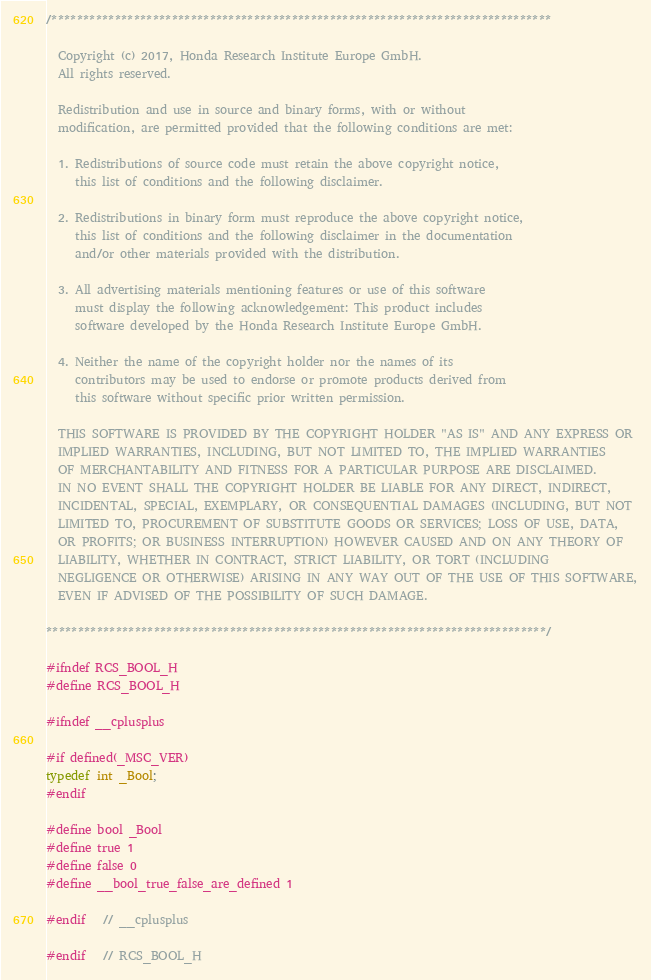<code> <loc_0><loc_0><loc_500><loc_500><_C_>/*******************************************************************************

  Copyright (c) 2017, Honda Research Institute Europe GmbH.
  All rights reserved.

  Redistribution and use in source and binary forms, with or without
  modification, are permitted provided that the following conditions are met:

  1. Redistributions of source code must retain the above copyright notice,
     this list of conditions and the following disclaimer.

  2. Redistributions in binary form must reproduce the above copyright notice,
     this list of conditions and the following disclaimer in the documentation
     and/or other materials provided with the distribution.

  3. All advertising materials mentioning features or use of this software
     must display the following acknowledgement: This product includes
     software developed by the Honda Research Institute Europe GmbH.

  4. Neither the name of the copyright holder nor the names of its
     contributors may be used to endorse or promote products derived from
     this software without specific prior written permission.

  THIS SOFTWARE IS PROVIDED BY THE COPYRIGHT HOLDER "AS IS" AND ANY EXPRESS OR
  IMPLIED WARRANTIES, INCLUDING, BUT NOT LIMITED TO, THE IMPLIED WARRANTIES
  OF MERCHANTABILITY AND FITNESS FOR A PARTICULAR PURPOSE ARE DISCLAIMED.
  IN NO EVENT SHALL THE COPYRIGHT HOLDER BE LIABLE FOR ANY DIRECT, INDIRECT,
  INCIDENTAL, SPECIAL, EXEMPLARY, OR CONSEQUENTIAL DAMAGES (INCLUDING, BUT NOT
  LIMITED TO, PROCUREMENT OF SUBSTITUTE GOODS OR SERVICES; LOSS OF USE, DATA,
  OR PROFITS; OR BUSINESS INTERRUPTION) HOWEVER CAUSED AND ON ANY THEORY OF
  LIABILITY, WHETHER IN CONTRACT, STRICT LIABILITY, OR TORT (INCLUDING
  NEGLIGENCE OR OTHERWISE) ARISING IN ANY WAY OUT OF THE USE OF THIS SOFTWARE,
  EVEN IF ADVISED OF THE POSSIBILITY OF SUCH DAMAGE.

*******************************************************************************/

#ifndef RCS_BOOL_H
#define RCS_BOOL_H

#ifndef __cplusplus

#if defined(_MSC_VER)
typedef int _Bool;
#endif

#define bool _Bool
#define true 1
#define false 0
#define __bool_true_false_are_defined 1

#endif   // __cplusplus

#endif   // RCS_BOOL_H
</code> 